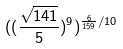<formula> <loc_0><loc_0><loc_500><loc_500>( ( \frac { \sqrt { 1 4 1 } } { 5 } ) ^ { 9 } ) ^ { \frac { 6 } { 1 5 9 } / 1 0 }</formula> 